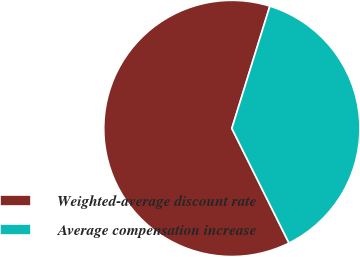Convert chart. <chart><loc_0><loc_0><loc_500><loc_500><pie_chart><fcel>Weighted-average discount rate<fcel>Average compensation increase<nl><fcel>62.16%<fcel>37.84%<nl></chart> 